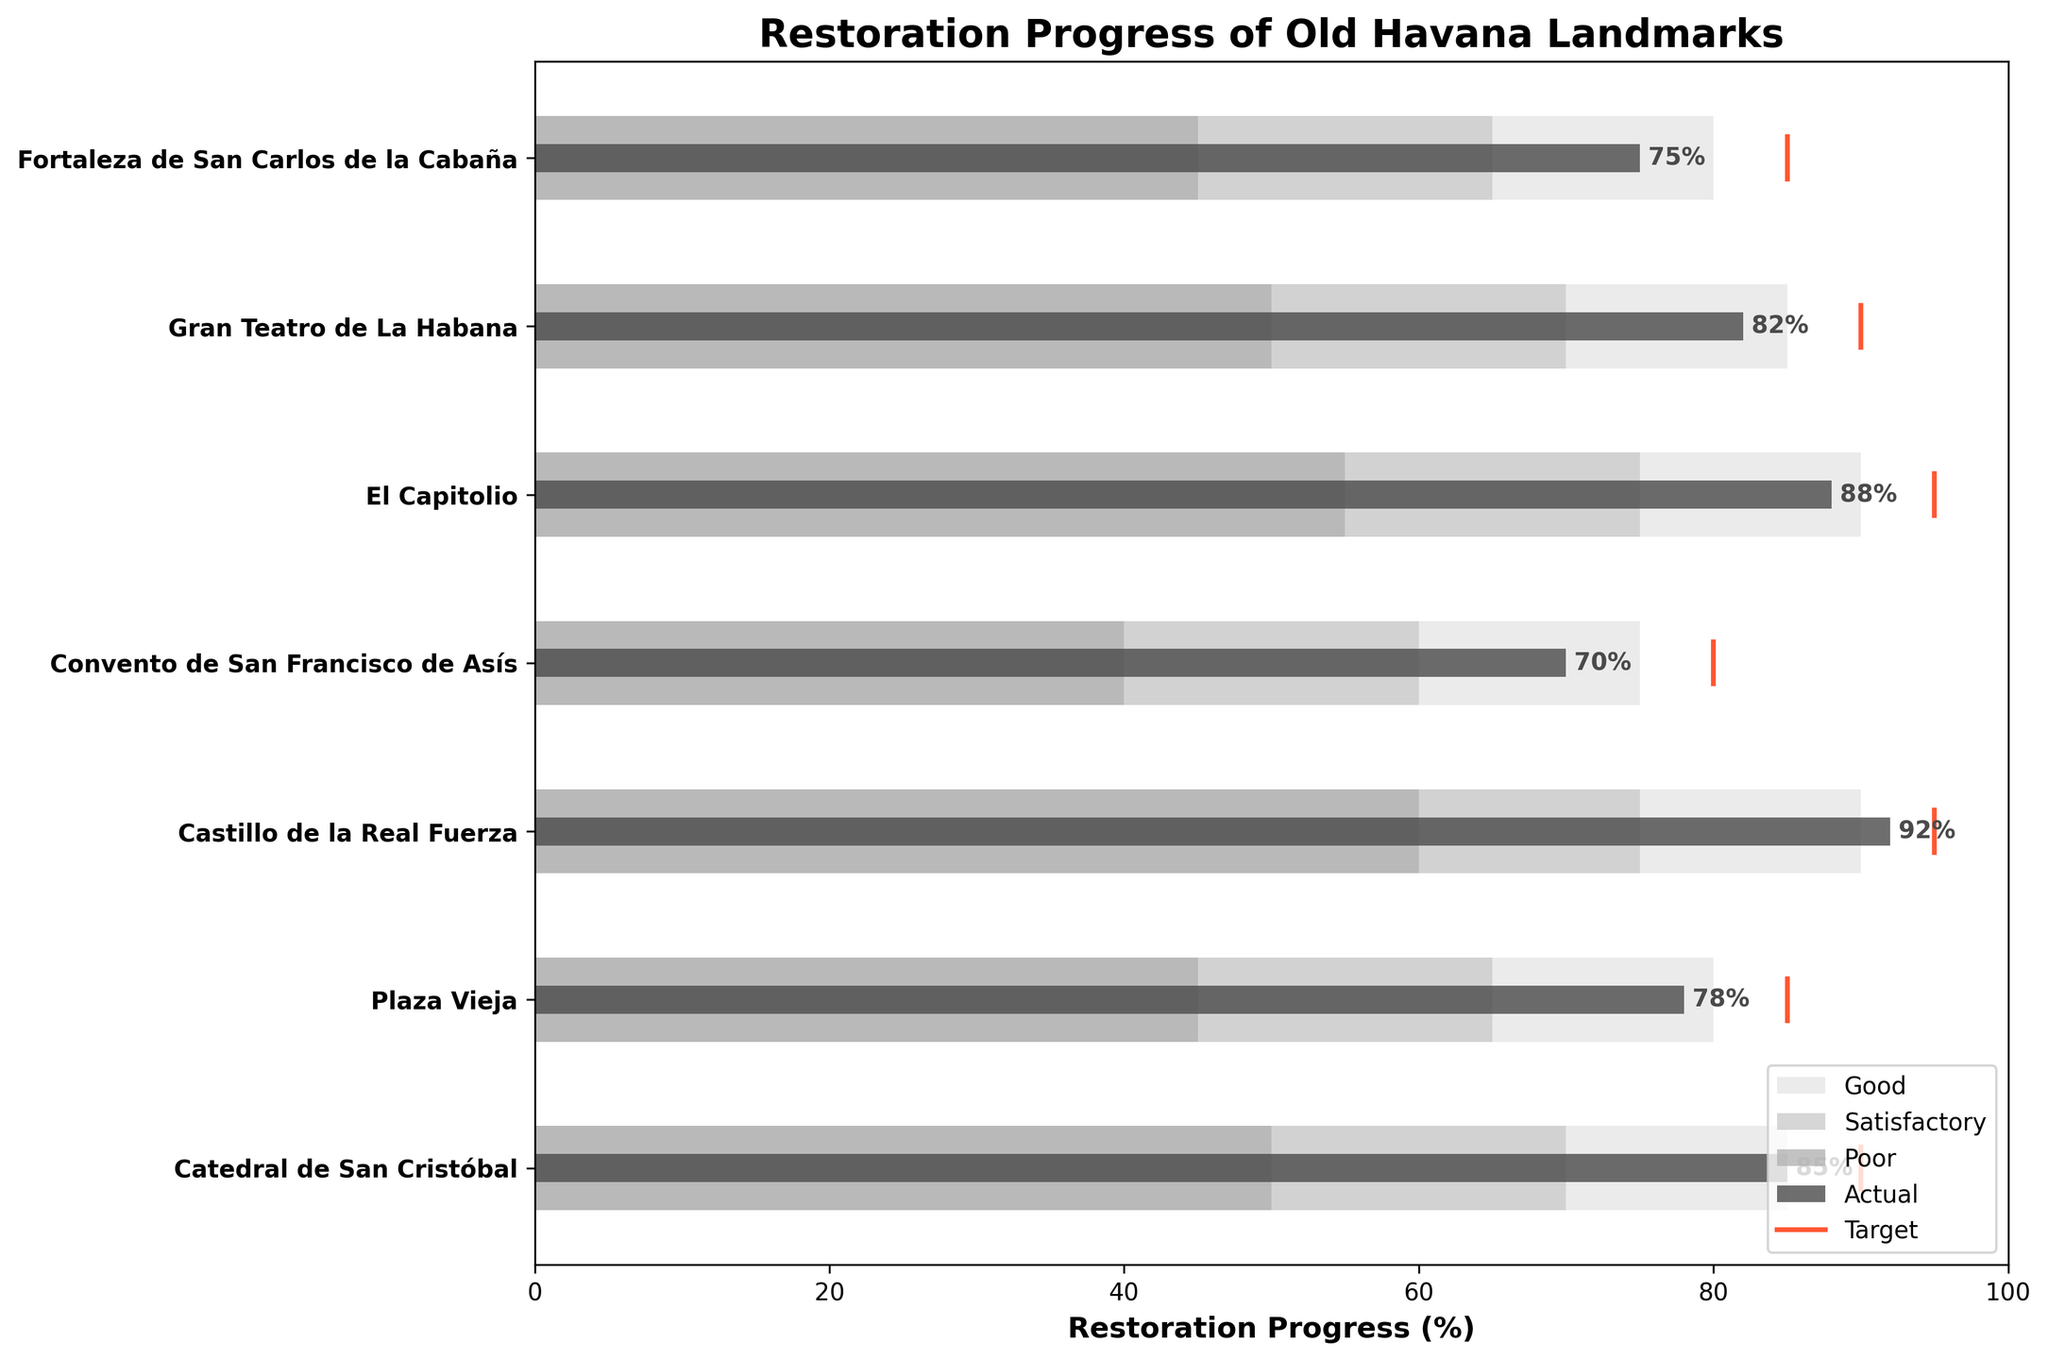What's the title of the chart? The title is usually placed at the top of a chart and is designed to provide a quick insight into what the chart depicts. Here, it is mentioned above the chart.
Answer: Restoration Progress of Old Havana Landmarks What is the highest restoration progress percentage achieved by any landmark? The landmarks' actual restoration progress percentages are represented by the solid bars in the chart. The highest percentage in these bars needs to be identified.
Answer: 92% Which landmark has the lowest actual restoration progress? By looking at the solid bars that extend the least from the leftmost side, the landmark with the smallest percentage can be identified.
Answer: Convento de San Francisco de Asís How many landmarks have met or exceeded their "Good" qualitative range? To answer the question, compare the length of each solid bar (actual progress) with its respective "Good" range (shaded region). Count the landmarks where the actual progress bar crosses the boundary of the "Good" region.
Answer: 3 What is the median value of actual restoration progress percentages of all landmarks? To find the median, list all actual progress percentages, order them, and identify the middle value. Percentages: 70, 75, 78, 82, 85, 88, 92. The middle value in this ordered list is the median.
Answer: 82% Which landmark has the smallest difference between its actual progress and target progress? Calculate the differences between actual and target percentages (subtract actual from target) for all landmarks and identify the smallest difference.
Answer: Catedral de San Cristóbal Which landmarks have actual progress percentages in the 'Satisfactory' range but not reaching 'Good'? Compare the actual progress bars' lengths with the defined satisfactory ranges for each landmark. Identify those within this range but not reaching the good threshold.
Answer: Plaza Vieja, Fortaleza de San Carlos de la Cabaña What is the overall trend of restoration progress among Old Havana landmarks? Analyzing the lengths of the solid bars and comparing them to their respective target lines and qualitative ranges gives an overall impression of progress trends.
Answer: Most landmarks are close to or exceed satisfactory levels; some reach good levels How many landmarks have missed their target progress by more than 10%? Calculate the absolute differences between actual and target progress for each landmark, then count those where the difference is greater than 10%.
Answer: 2 